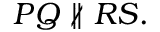Convert formula to latex. <formula><loc_0><loc_0><loc_500><loc_500>P Q \not \| R S .</formula> 